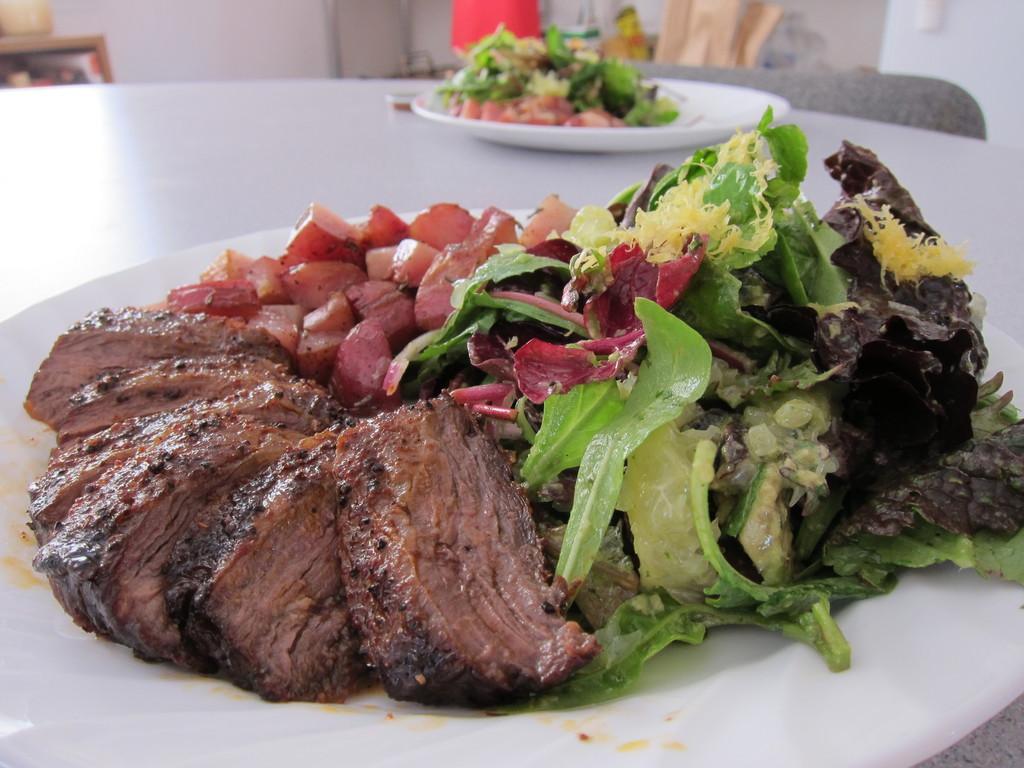Can you describe this image briefly? In this image there is a table and we can see plates containing food placed on the table. In the background there is a wall. 